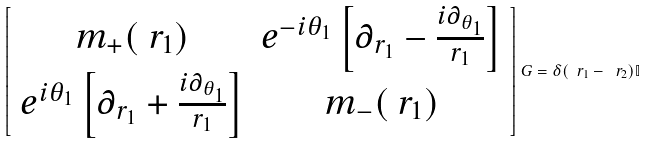<formula> <loc_0><loc_0><loc_500><loc_500>\left [ \begin{array} { c c } m _ { + } ( \ r _ { 1 } ) & e ^ { - i \theta _ { 1 } } \left [ \partial _ { r _ { 1 } } - \frac { i \partial _ { \theta _ { 1 } } } { r _ { 1 } } \right ] \\ e ^ { i \theta _ { 1 } } \left [ \partial _ { r _ { 1 } } + \frac { i \partial _ { \theta _ { 1 } } } { r _ { 1 } } \right ] & m _ { - } ( \ r _ { 1 } ) \end{array} \right ] G = \delta ( \ r _ { 1 } - \ r _ { 2 } ) \mathbb { I }</formula> 